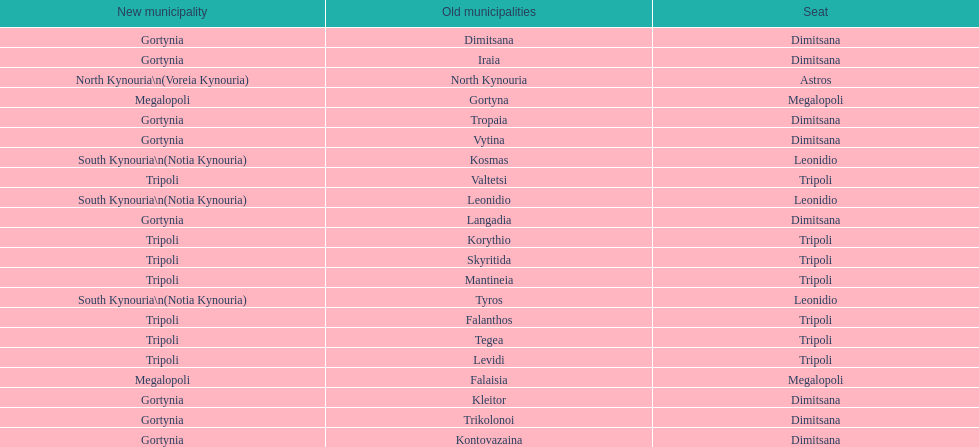Is tripoli still considered a municipality in arcadia since its 2011 reformation? Yes. 